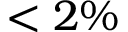Convert formula to latex. <formula><loc_0><loc_0><loc_500><loc_500>< 2 \%</formula> 